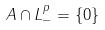Convert formula to latex. <formula><loc_0><loc_0><loc_500><loc_500>A \cap L _ { - } ^ { p } = \{ 0 \}</formula> 